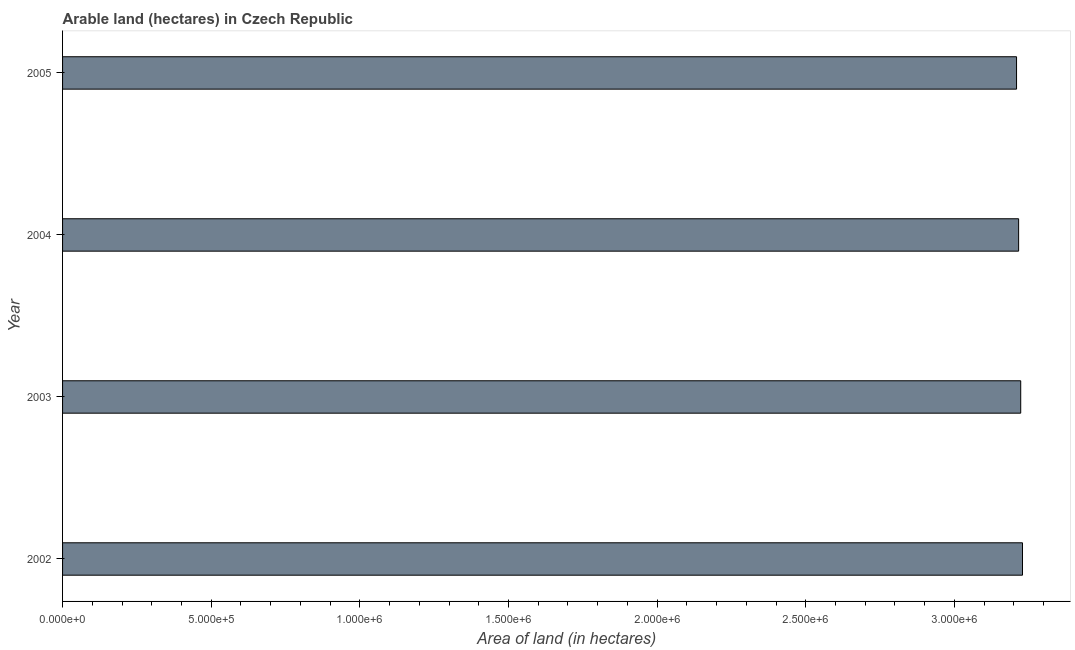Does the graph contain any zero values?
Your response must be concise. No. What is the title of the graph?
Offer a very short reply. Arable land (hectares) in Czech Republic. What is the label or title of the X-axis?
Provide a short and direct response. Area of land (in hectares). What is the area of land in 2003?
Provide a succinct answer. 3.22e+06. Across all years, what is the maximum area of land?
Keep it short and to the point. 3.23e+06. Across all years, what is the minimum area of land?
Keep it short and to the point. 3.21e+06. In which year was the area of land maximum?
Your response must be concise. 2002. In which year was the area of land minimum?
Give a very brief answer. 2005. What is the sum of the area of land?
Your answer should be very brief. 1.29e+07. What is the difference between the area of land in 2004 and 2005?
Provide a succinct answer. 7000. What is the average area of land per year?
Your answer should be compact. 3.22e+06. What is the median area of land?
Make the answer very short. 3.22e+06. Do a majority of the years between 2002 and 2004 (inclusive) have area of land greater than 800000 hectares?
Your response must be concise. Yes. What is the ratio of the area of land in 2004 to that in 2005?
Your answer should be compact. 1. Is the area of land in 2002 less than that in 2005?
Your answer should be very brief. No. What is the difference between the highest and the second highest area of land?
Your answer should be very brief. 6000. What is the difference between the highest and the lowest area of land?
Your answer should be compact. 2.00e+04. How many bars are there?
Ensure brevity in your answer.  4. Are all the bars in the graph horizontal?
Your response must be concise. Yes. How many years are there in the graph?
Keep it short and to the point. 4. What is the Area of land (in hectares) of 2002?
Provide a short and direct response. 3.23e+06. What is the Area of land (in hectares) of 2003?
Keep it short and to the point. 3.22e+06. What is the Area of land (in hectares) of 2004?
Your answer should be very brief. 3.22e+06. What is the Area of land (in hectares) of 2005?
Keep it short and to the point. 3.21e+06. What is the difference between the Area of land (in hectares) in 2002 and 2003?
Provide a short and direct response. 6000. What is the difference between the Area of land (in hectares) in 2002 and 2004?
Offer a terse response. 1.30e+04. What is the difference between the Area of land (in hectares) in 2003 and 2004?
Provide a succinct answer. 7000. What is the difference between the Area of land (in hectares) in 2003 and 2005?
Provide a succinct answer. 1.40e+04. What is the difference between the Area of land (in hectares) in 2004 and 2005?
Offer a terse response. 7000. What is the ratio of the Area of land (in hectares) in 2002 to that in 2004?
Offer a terse response. 1. What is the ratio of the Area of land (in hectares) in 2002 to that in 2005?
Give a very brief answer. 1.01. What is the ratio of the Area of land (in hectares) in 2004 to that in 2005?
Provide a short and direct response. 1. 